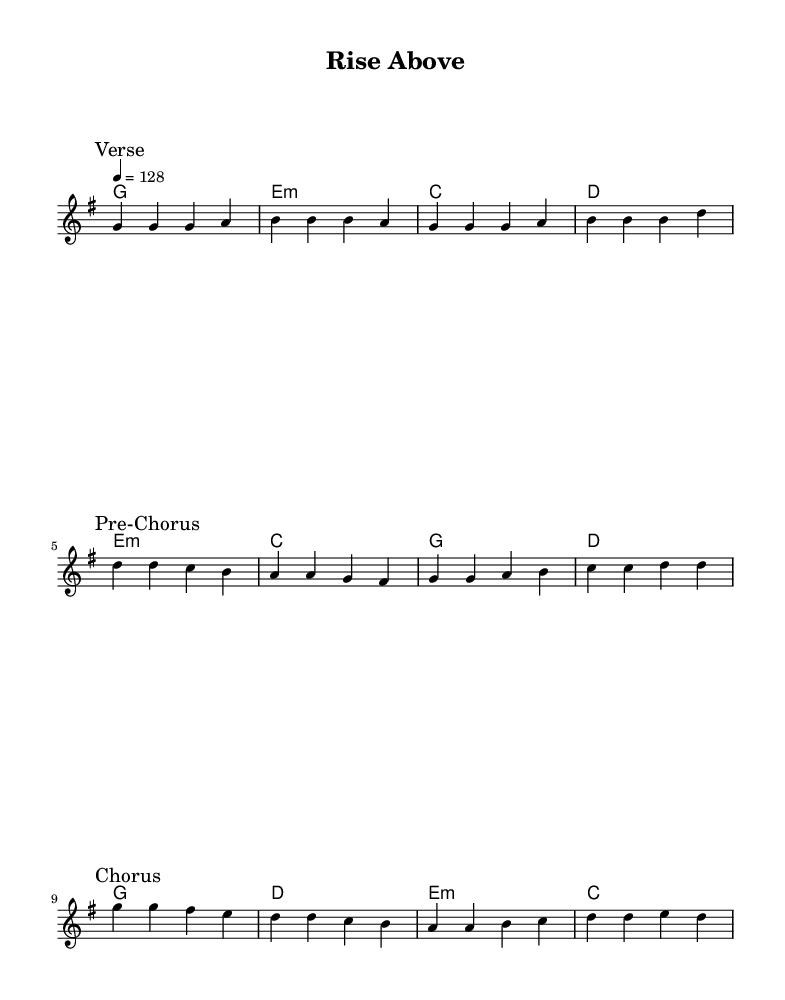What is the key signature of this music? The key signature is G major, which has one sharp (F#). You can find this by looking at the “\key g \major” in the global section of the code.
Answer: G major What is the time signature of this music? The time signature is 4/4, which allows for four beats per measure. This is indicated by “\time 4/4” in the code.
Answer: 4/4 What is the tempo marking in this music? The tempo is marked as 128 beats per minute from the “\tempo 4 = 128” instruction in the code.
Answer: 128 What is the overall theme of the lyrics? The lyrics focus on motivation and overcoming challenges, as suggested by lines referencing climbing, breaking free, and reaching for the sky throughout the verses and chorus. This theme is typical of motivational pop anthems.
Answer: Motivation How many sections are present in the song structure? The music consists of three sections: Verse, Pre-Chorus, and Chorus, as indicated by the corresponding marks in the code. You can count them by looking for the "\mark" indicators.
Answer: Three What are the first two words of the chorus? The first two words of the chorus are “I will,” which are the opening words of the chorus section in the lyrics.
Answer: I will What chords are used in the chorus? The chords used in the chorus are G, D, A, and D, as indicated in the “\harmonies” section under the Chorus measure. You can identify them by the chord names aligned with the melody notes.
Answer: G, D, A, D 